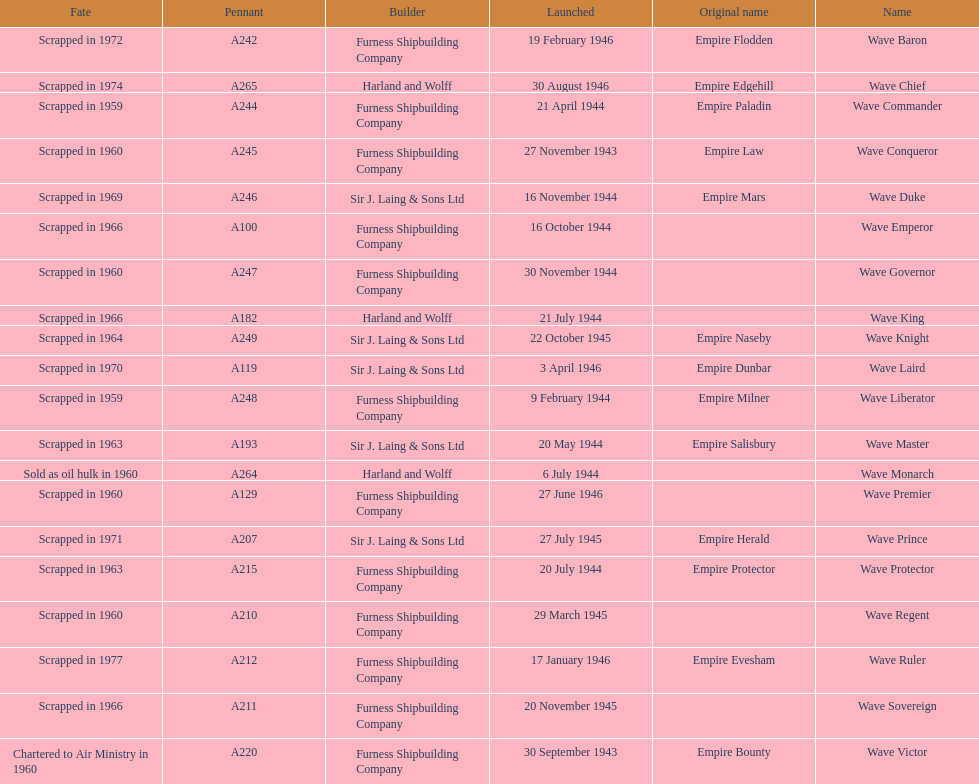How many ships were launched in the year 1944? 9. 